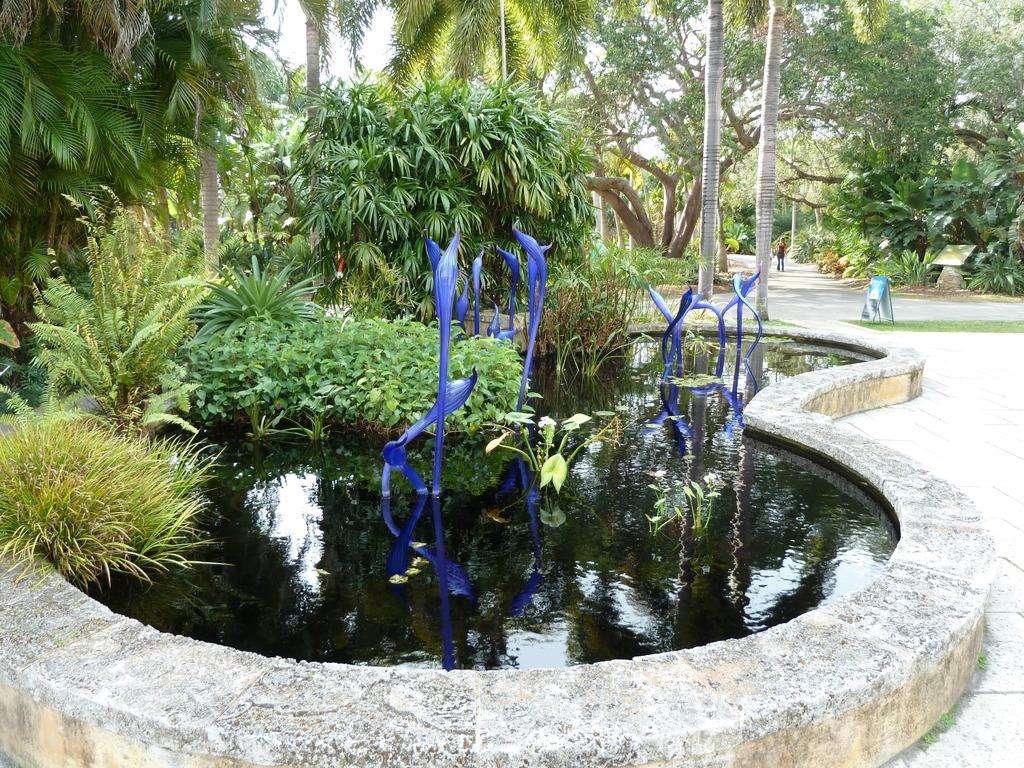What is happening with the plants in the image? The plants are in the water in the image. What type of vegetation can be seen in the image besides the plants in the water? There are trees visible in the image. What is visible in the background of the image? The sky is visible in the image. Can you describe the person in the image? There is a person standing on a path in the image. What type of rail can be seen in the image? There is no rail present in the image. Is the person wearing a suit in the image? The image does not provide information about the person's clothing, so it cannot be determined if they are wearing a suit. 